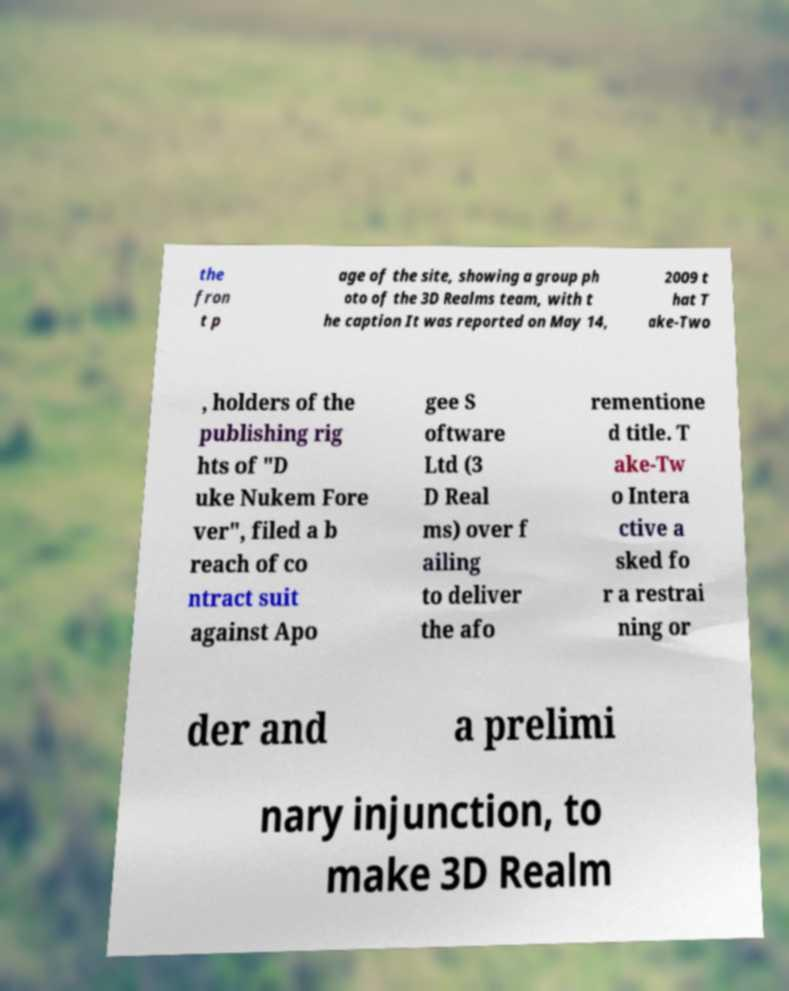There's text embedded in this image that I need extracted. Can you transcribe it verbatim? the fron t p age of the site, showing a group ph oto of the 3D Realms team, with t he caption It was reported on May 14, 2009 t hat T ake-Two , holders of the publishing rig hts of "D uke Nukem Fore ver", filed a b reach of co ntract suit against Apo gee S oftware Ltd (3 D Real ms) over f ailing to deliver the afo rementione d title. T ake-Tw o Intera ctive a sked fo r a restrai ning or der and a prelimi nary injunction, to make 3D Realm 